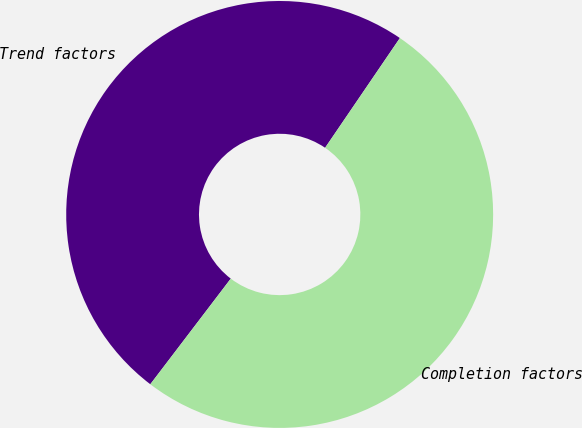Convert chart. <chart><loc_0><loc_0><loc_500><loc_500><pie_chart><fcel>Trend factors<fcel>Completion factors<nl><fcel>49.16%<fcel>50.84%<nl></chart> 